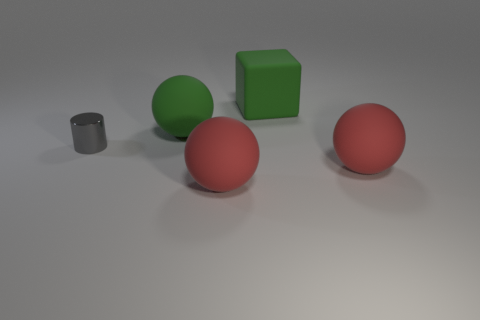Is there anything else that has the same shape as the small metal object?
Provide a succinct answer. No. What size is the rubber sphere behind the object that is left of the sphere behind the gray cylinder?
Ensure brevity in your answer.  Large. There is a matte object that is both behind the tiny gray metallic thing and on the left side of the big green rubber cube; what shape is it?
Provide a succinct answer. Sphere. Are there an equal number of green matte things that are on the left side of the tiny metallic thing and things that are behind the big green matte sphere?
Your answer should be very brief. No. Are there any yellow cylinders that have the same material as the tiny gray cylinder?
Offer a very short reply. No. Does the big green thing that is in front of the green rubber cube have the same material as the big green block?
Offer a very short reply. Yes. What is the size of the rubber ball that is both left of the rubber block and in front of the big green ball?
Give a very brief answer. Large. The cylinder has what color?
Offer a very short reply. Gray. What number of small gray objects are there?
Offer a very short reply. 1. What number of big matte things have the same color as the block?
Keep it short and to the point. 1. 